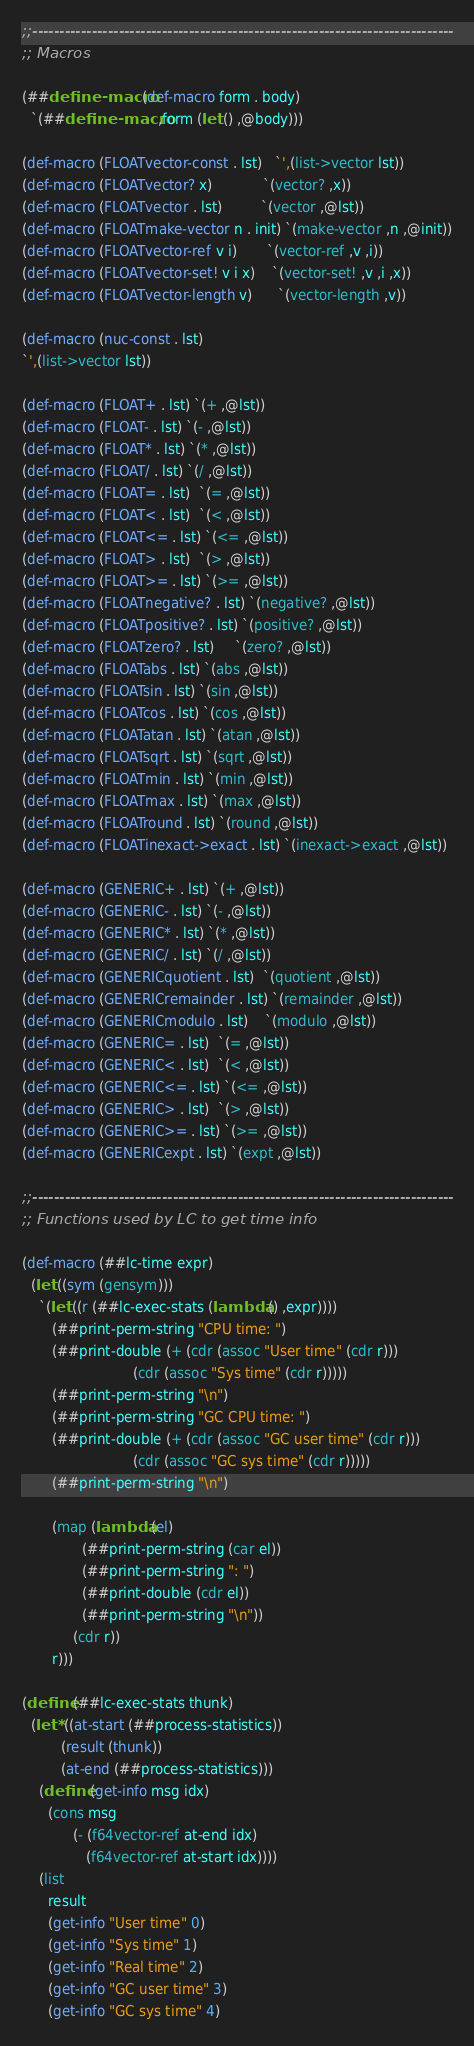<code> <loc_0><loc_0><loc_500><loc_500><_Scheme_>;;------------------------------------------------------------------------------
;; Macros

(##define-macro (def-macro form . body)
  `(##define-macro ,form (let () ,@body)))

(def-macro (FLOATvector-const . lst)   `',(list->vector lst))
(def-macro (FLOATvector? x)            `(vector? ,x))
(def-macro (FLOATvector . lst)         `(vector ,@lst))
(def-macro (FLOATmake-vector n . init) `(make-vector ,n ,@init))
(def-macro (FLOATvector-ref v i)       `(vector-ref ,v ,i))
(def-macro (FLOATvector-set! v i x)    `(vector-set! ,v ,i ,x))
(def-macro (FLOATvector-length v)      `(vector-length ,v))

(def-macro (nuc-const . lst)
`',(list->vector lst))

(def-macro (FLOAT+ . lst) `(+ ,@lst))
(def-macro (FLOAT- . lst) `(- ,@lst))
(def-macro (FLOAT* . lst) `(* ,@lst))
(def-macro (FLOAT/ . lst) `(/ ,@lst))
(def-macro (FLOAT= . lst)  `(= ,@lst))
(def-macro (FLOAT< . lst)  `(< ,@lst))
(def-macro (FLOAT<= . lst) `(<= ,@lst))
(def-macro (FLOAT> . lst)  `(> ,@lst))
(def-macro (FLOAT>= . lst) `(>= ,@lst))
(def-macro (FLOATnegative? . lst) `(negative? ,@lst))
(def-macro (FLOATpositive? . lst) `(positive? ,@lst))
(def-macro (FLOATzero? . lst)     `(zero? ,@lst))
(def-macro (FLOATabs . lst) `(abs ,@lst))
(def-macro (FLOATsin . lst) `(sin ,@lst))
(def-macro (FLOATcos . lst) `(cos ,@lst))
(def-macro (FLOATatan . lst) `(atan ,@lst))
(def-macro (FLOATsqrt . lst) `(sqrt ,@lst))
(def-macro (FLOATmin . lst) `(min ,@lst))
(def-macro (FLOATmax . lst) `(max ,@lst))
(def-macro (FLOATround . lst) `(round ,@lst))
(def-macro (FLOATinexact->exact . lst) `(inexact->exact ,@lst))

(def-macro (GENERIC+ . lst) `(+ ,@lst))
(def-macro (GENERIC- . lst) `(- ,@lst))
(def-macro (GENERIC* . lst) `(* ,@lst))
(def-macro (GENERIC/ . lst) `(/ ,@lst))
(def-macro (GENERICquotient . lst)  `(quotient ,@lst))
(def-macro (GENERICremainder . lst) `(remainder ,@lst))
(def-macro (GENERICmodulo . lst)    `(modulo ,@lst))
(def-macro (GENERIC= . lst)  `(= ,@lst))
(def-macro (GENERIC< . lst)  `(< ,@lst))
(def-macro (GENERIC<= . lst) `(<= ,@lst))
(def-macro (GENERIC> . lst)  `(> ,@lst))
(def-macro (GENERIC>= . lst) `(>= ,@lst))
(def-macro (GENERICexpt . lst) `(expt ,@lst))

;;------------------------------------------------------------------------------
;; Functions used by LC to get time info

(def-macro (##lc-time expr)
  (let ((sym (gensym)))
    `(let ((r (##lc-exec-stats (lambda () ,expr))))
       (##print-perm-string "CPU time: ")
       (##print-double (+ (cdr (assoc "User time" (cdr r)))
                          (cdr (assoc "Sys time" (cdr r)))))
       (##print-perm-string "\n")
       (##print-perm-string "GC CPU time: ")
       (##print-double (+ (cdr (assoc "GC user time" (cdr r)))
                          (cdr (assoc "GC sys time" (cdr r)))))
       (##print-perm-string "\n")

       (map (lambda (el)
              (##print-perm-string (car el))
              (##print-perm-string ": ")
              (##print-double (cdr el))
              (##print-perm-string "\n"))
            (cdr r))
       r)))

(define (##lc-exec-stats thunk)
  (let* ((at-start (##process-statistics))
         (result (thunk))
         (at-end (##process-statistics)))
    (define (get-info msg idx)
      (cons msg
            (- (f64vector-ref at-end idx)
               (f64vector-ref at-start idx))))
    (list
      result
      (get-info "User time" 0)
      (get-info "Sys time" 1)
      (get-info "Real time" 2)
      (get-info "GC user time" 3)
      (get-info "GC sys time" 4)</code> 